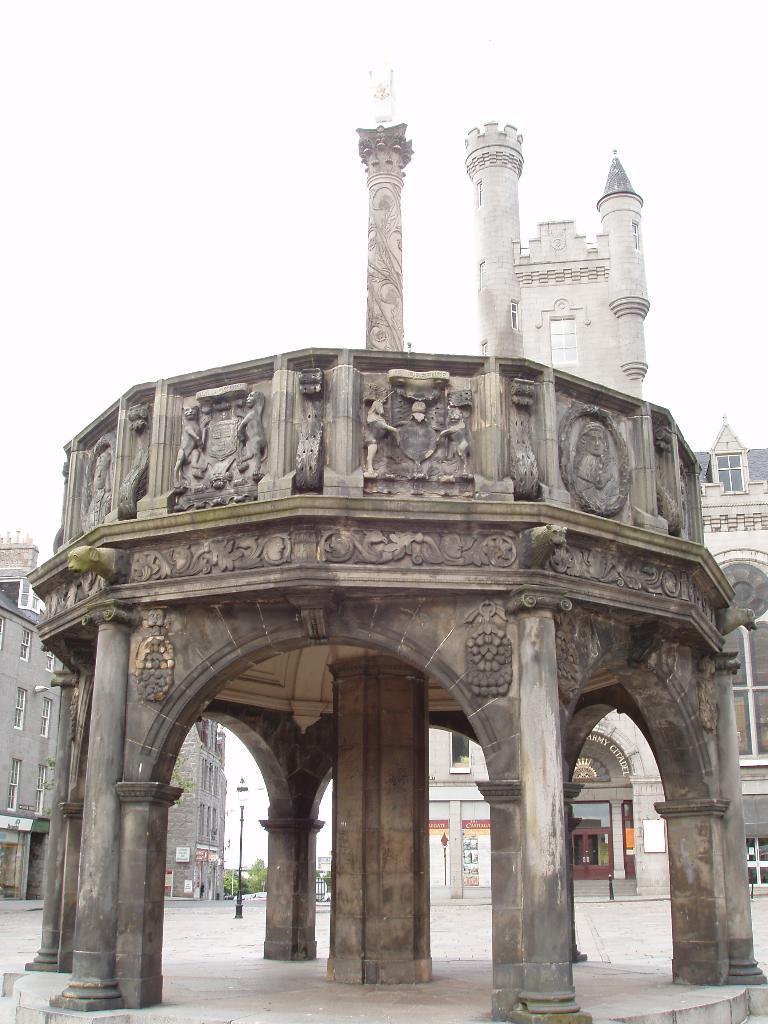Please provide a concise description of this image. In this picture we can see pillars and statues on the wall. In the background of the image we can see buildings, light on pole, boards, trees and sky. 